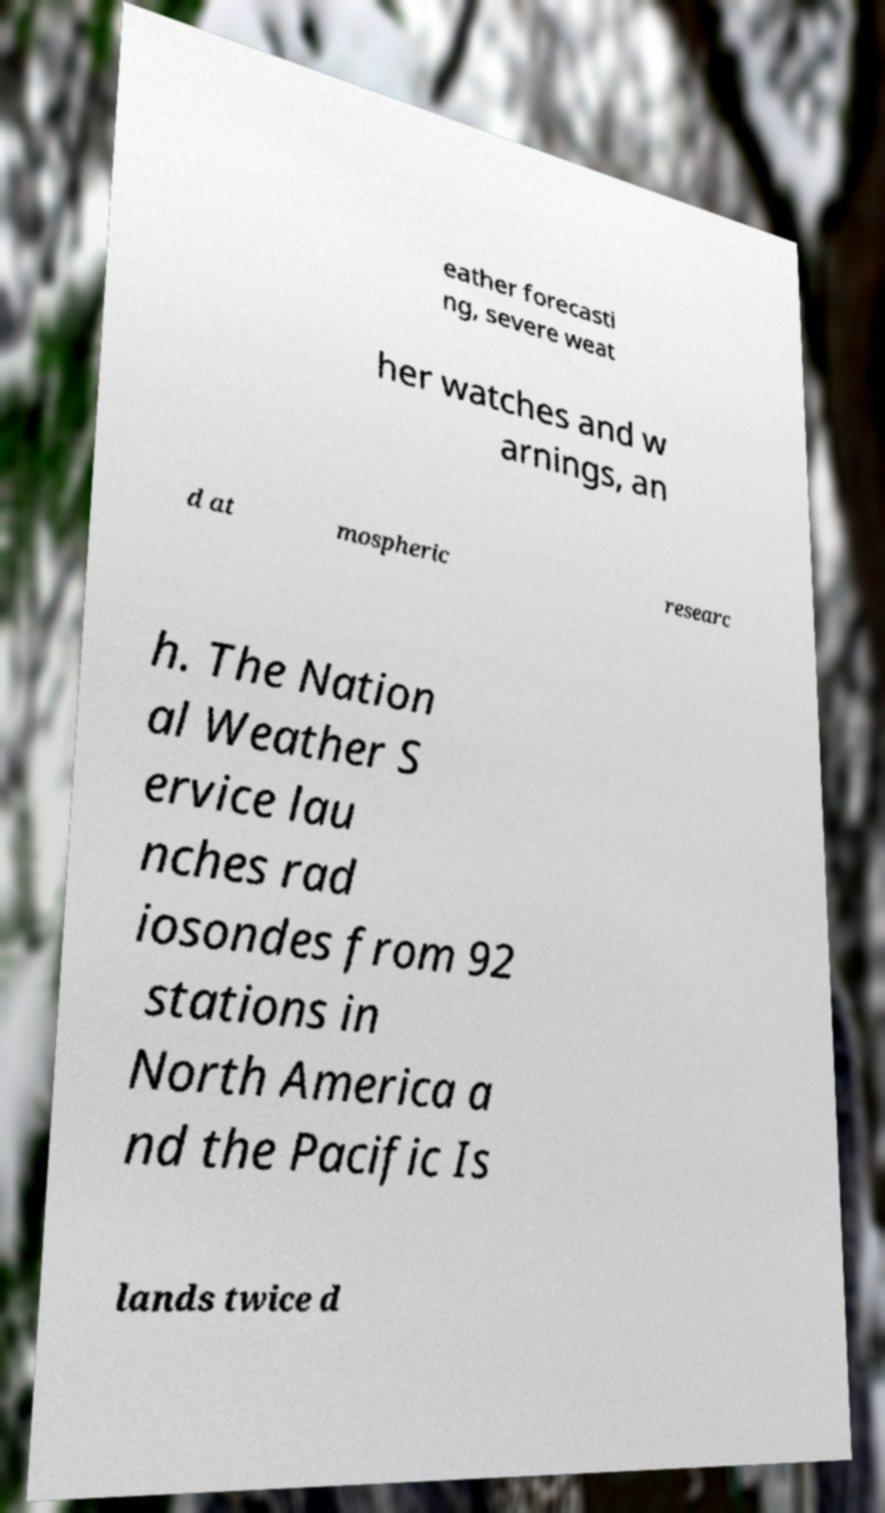There's text embedded in this image that I need extracted. Can you transcribe it verbatim? eather forecasti ng, severe weat her watches and w arnings, an d at mospheric researc h. The Nation al Weather S ervice lau nches rad iosondes from 92 stations in North America a nd the Pacific Is lands twice d 